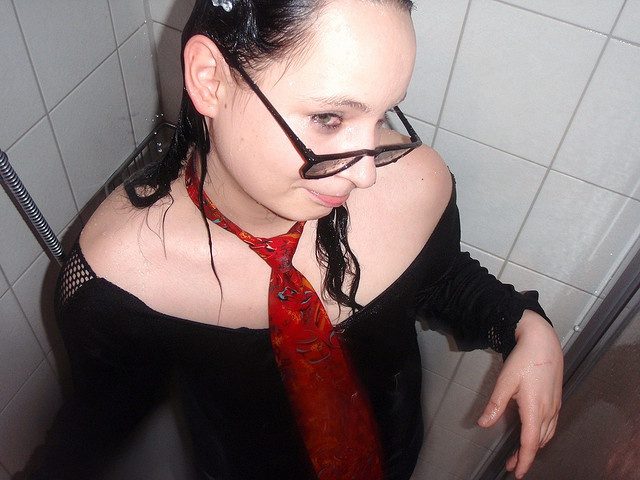Describe the objects in this image and their specific colors. I can see people in darkgray, black, pink, lightpink, and maroon tones and tie in darkgray, maroon, black, brown, and lightpink tones in this image. 